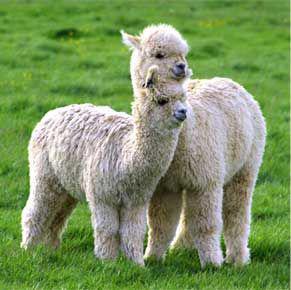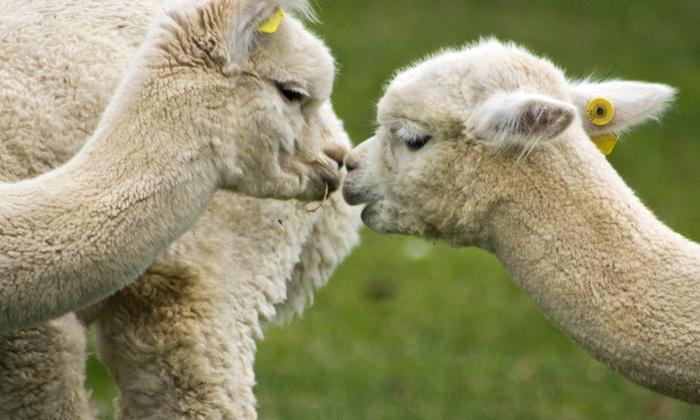The first image is the image on the left, the second image is the image on the right. Considering the images on both sides, is "Two white llamas of similar size are in a kissing pose in the right image." valid? Answer yes or no. Yes. 